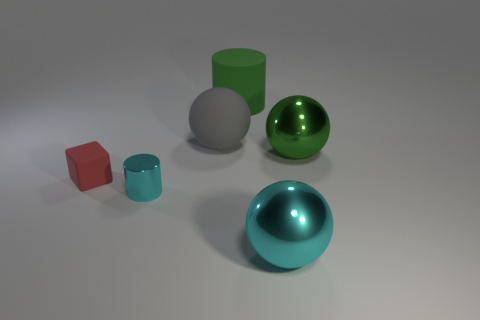Add 2 green balls. How many objects exist? 8 Subtract all cylinders. How many objects are left? 4 Subtract all matte spheres. Subtract all large gray rubber objects. How many objects are left? 4 Add 4 tiny red things. How many tiny red things are left? 5 Add 5 large matte cylinders. How many large matte cylinders exist? 6 Subtract 1 gray spheres. How many objects are left? 5 